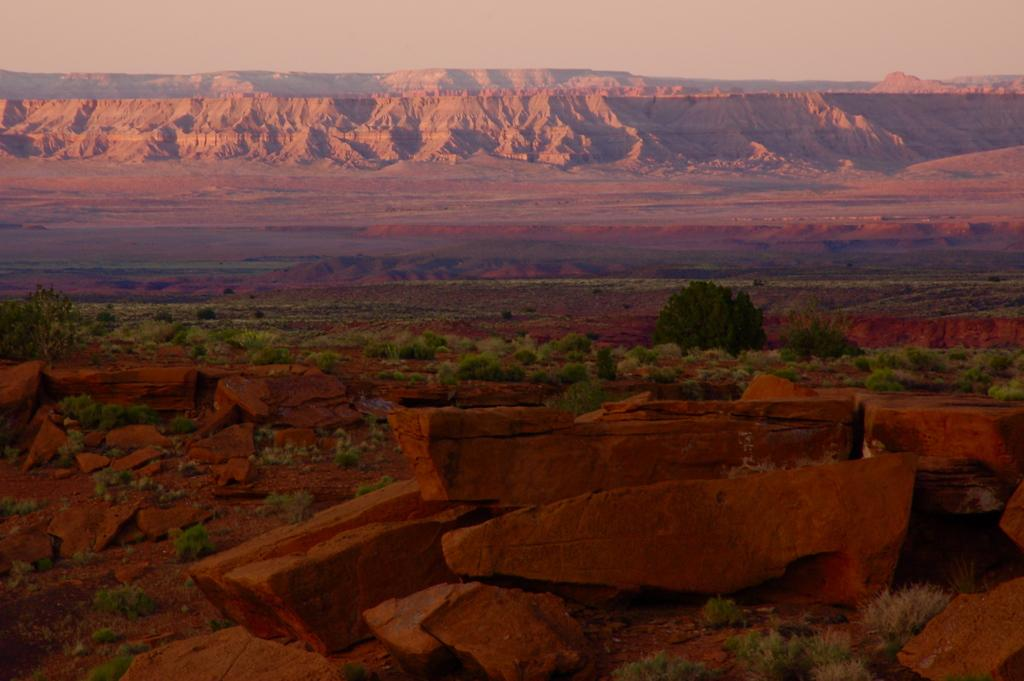What type of natural elements can be seen in the image? There are stones and plants in the image. Where are the plants located in the image? The plants are in the center of the image. What can be seen in the background of the image? There are mountains in the background of the image. What type of map can be seen in the image? There is no map present in the image; it features stones, plants, and mountains. What knowledge can be gained from the image? The image provides visual information about the presence of stones, plants, and mountains, but it does not convey specific knowledge or facts. 